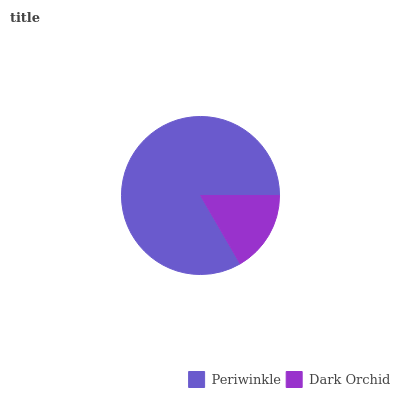Is Dark Orchid the minimum?
Answer yes or no. Yes. Is Periwinkle the maximum?
Answer yes or no. Yes. Is Dark Orchid the maximum?
Answer yes or no. No. Is Periwinkle greater than Dark Orchid?
Answer yes or no. Yes. Is Dark Orchid less than Periwinkle?
Answer yes or no. Yes. Is Dark Orchid greater than Periwinkle?
Answer yes or no. No. Is Periwinkle less than Dark Orchid?
Answer yes or no. No. Is Periwinkle the high median?
Answer yes or no. Yes. Is Dark Orchid the low median?
Answer yes or no. Yes. Is Dark Orchid the high median?
Answer yes or no. No. Is Periwinkle the low median?
Answer yes or no. No. 